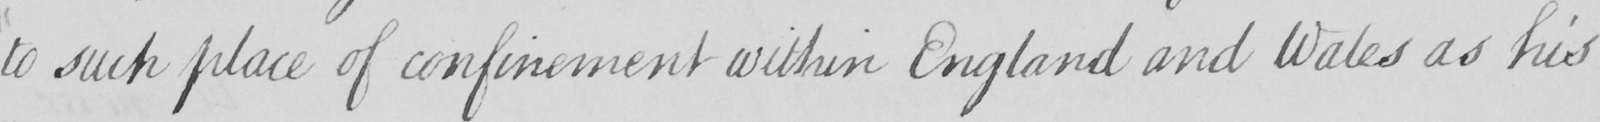What text is written in this handwritten line? to such place of confinement within England and Wales as his 